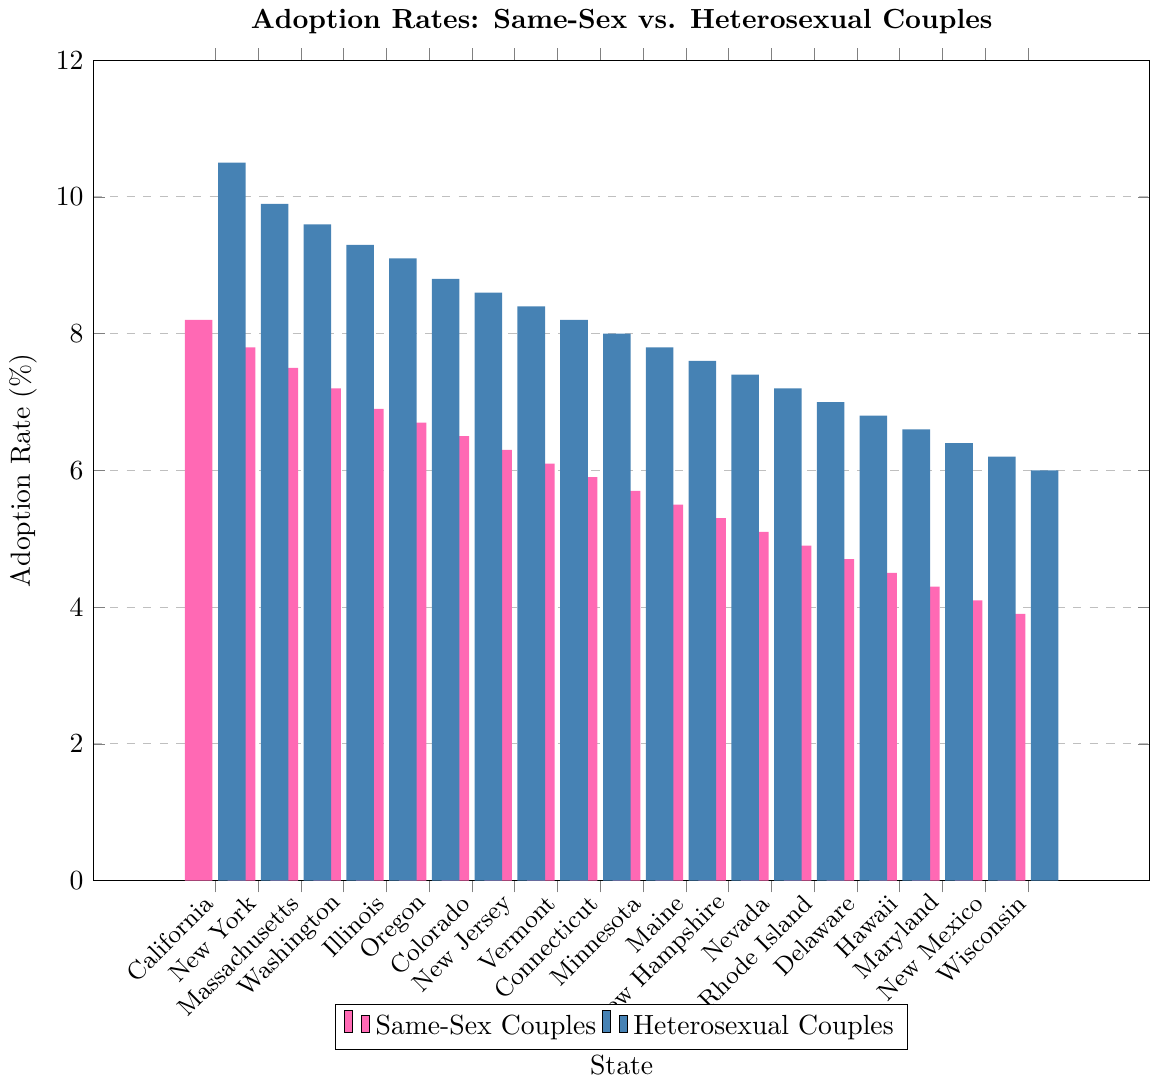What's the average adoption rate for same-sex couples across all states? Sum the adoption rates for same-sex couples (8.2 + 7.8 + 7.5 + 7.2 + 6.9 + 6.7 + 6.5 + 6.3 + 6.1 + 5.9 + 5.7 + 5.5 + 5.3 + 5.1 + 4.9 + 4.7 + 4.5 + 4.3 + 4.1 + 3.9) = 117.4. Divide this by the number of states (20) to get the average: 117.4 / 20 = 5.87
Answer: 5.87 Which state has the highest adoption rate for same-sex couples? Find the state with the highest bar in the color representing same-sex couples. California (8.2%) has the highest adoption rate for same-sex couples.
Answer: California What is the difference in adoption rates between same-sex and heterosexual couples in Oregon? Look at the values for Oregon: 6.7 for same-sex couples and 8.8 for heterosexual couples. Subtract the two values: 8.8 - 6.7 = 2.1
Answer: 2.1 In which state is the adoption rate for same-sex couples just 0.3 less than New York’s rate for same-sex couples? New York has an adoption rate of 7.8 for same-sex couples. Look for a state with an adoption rate of 7.8 - 0.3 = 7.5, which is Massachusetts.
Answer: Massachusetts What's the median adoption rate for heterosexual couples across all states? Arrange the adoption rates for heterosexual couples in ascending order: 6.0, 6.2, 6.4, 6.6, 6.8, 7.0, 7.2, 7.4, 7.6, 7.8, 8.0, 8.2, 8.4, 8.6, 8.8, 9.1, 9.3, 9.6, 9.9, 10.5. As there are 20 values, the median lies between the 10th and 11th values: (7.8 + 8.0) / 2 = 7.9
Answer: 7.9 Which state has the closest same-sex adoption rate to the average rate across all states? The average adoption rate for same-sex couples is 5.87. Check each state’s rate to find the closest. Connecticut has a rate of 5.9, which is the closest to 5.87.
Answer: Connecticut Between New Jersey and Maryland, which state has a higher adoption rate for heterosexual couples? Compare the values: New Jersey has a rate of 8.4, while Maryland has a rate of 6.4. Thus, New Jersey has the higher adoption rate.
Answer: New Jersey Is there any state where the adoption rate for same-sex couples is higher than that for heterosexual couples? Check each pair of values; in all cases, the bar representing heterosexual couples is higher. Thus, there is no state where the same-sex adoption rate is higher.
Answer: No How much lower is the lowest adoption rate for same-sex couples compared to heterosexual couples? Identify the lowest adoption rates: 3.9 for same-sex couples (Wisconsin) and 6.0 for heterosexual couples (also Wisconsin). The difference is 6.0 - 3.9 = 2.1
Answer: 2.1 Which state shows the smallest difference between same-sex and heterosexual adoption rates? Calculate the difference for each state and identify the smallest: Vermont has rates of 6.1 (same-sex) and 8.2 (heterosexual), resulting in a difference of 8.2 - 6.1 = 2.1. It seems two states (Oregon and Wisconsin also have a difference of 2.1).
Answer: Vermont, Oregon, Wisconsin 